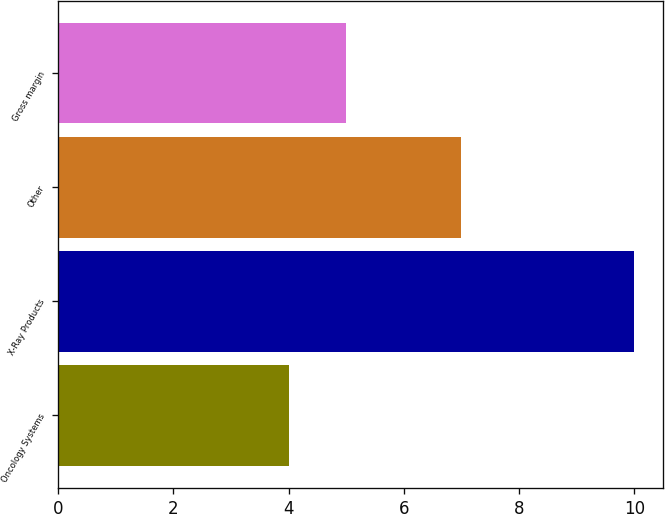Convert chart to OTSL. <chart><loc_0><loc_0><loc_500><loc_500><bar_chart><fcel>Oncology Systems<fcel>X-Ray Products<fcel>Other<fcel>Gross margin<nl><fcel>4<fcel>10<fcel>7<fcel>5<nl></chart> 